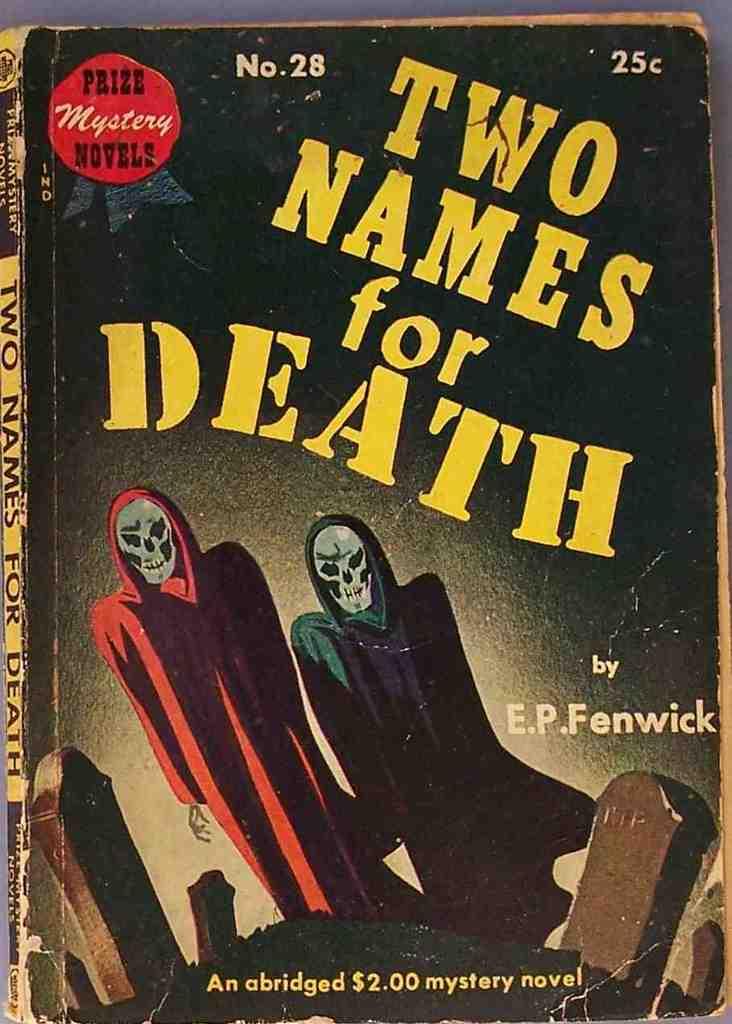Are there more than two reapers in the book?
Provide a succinct answer. No. 